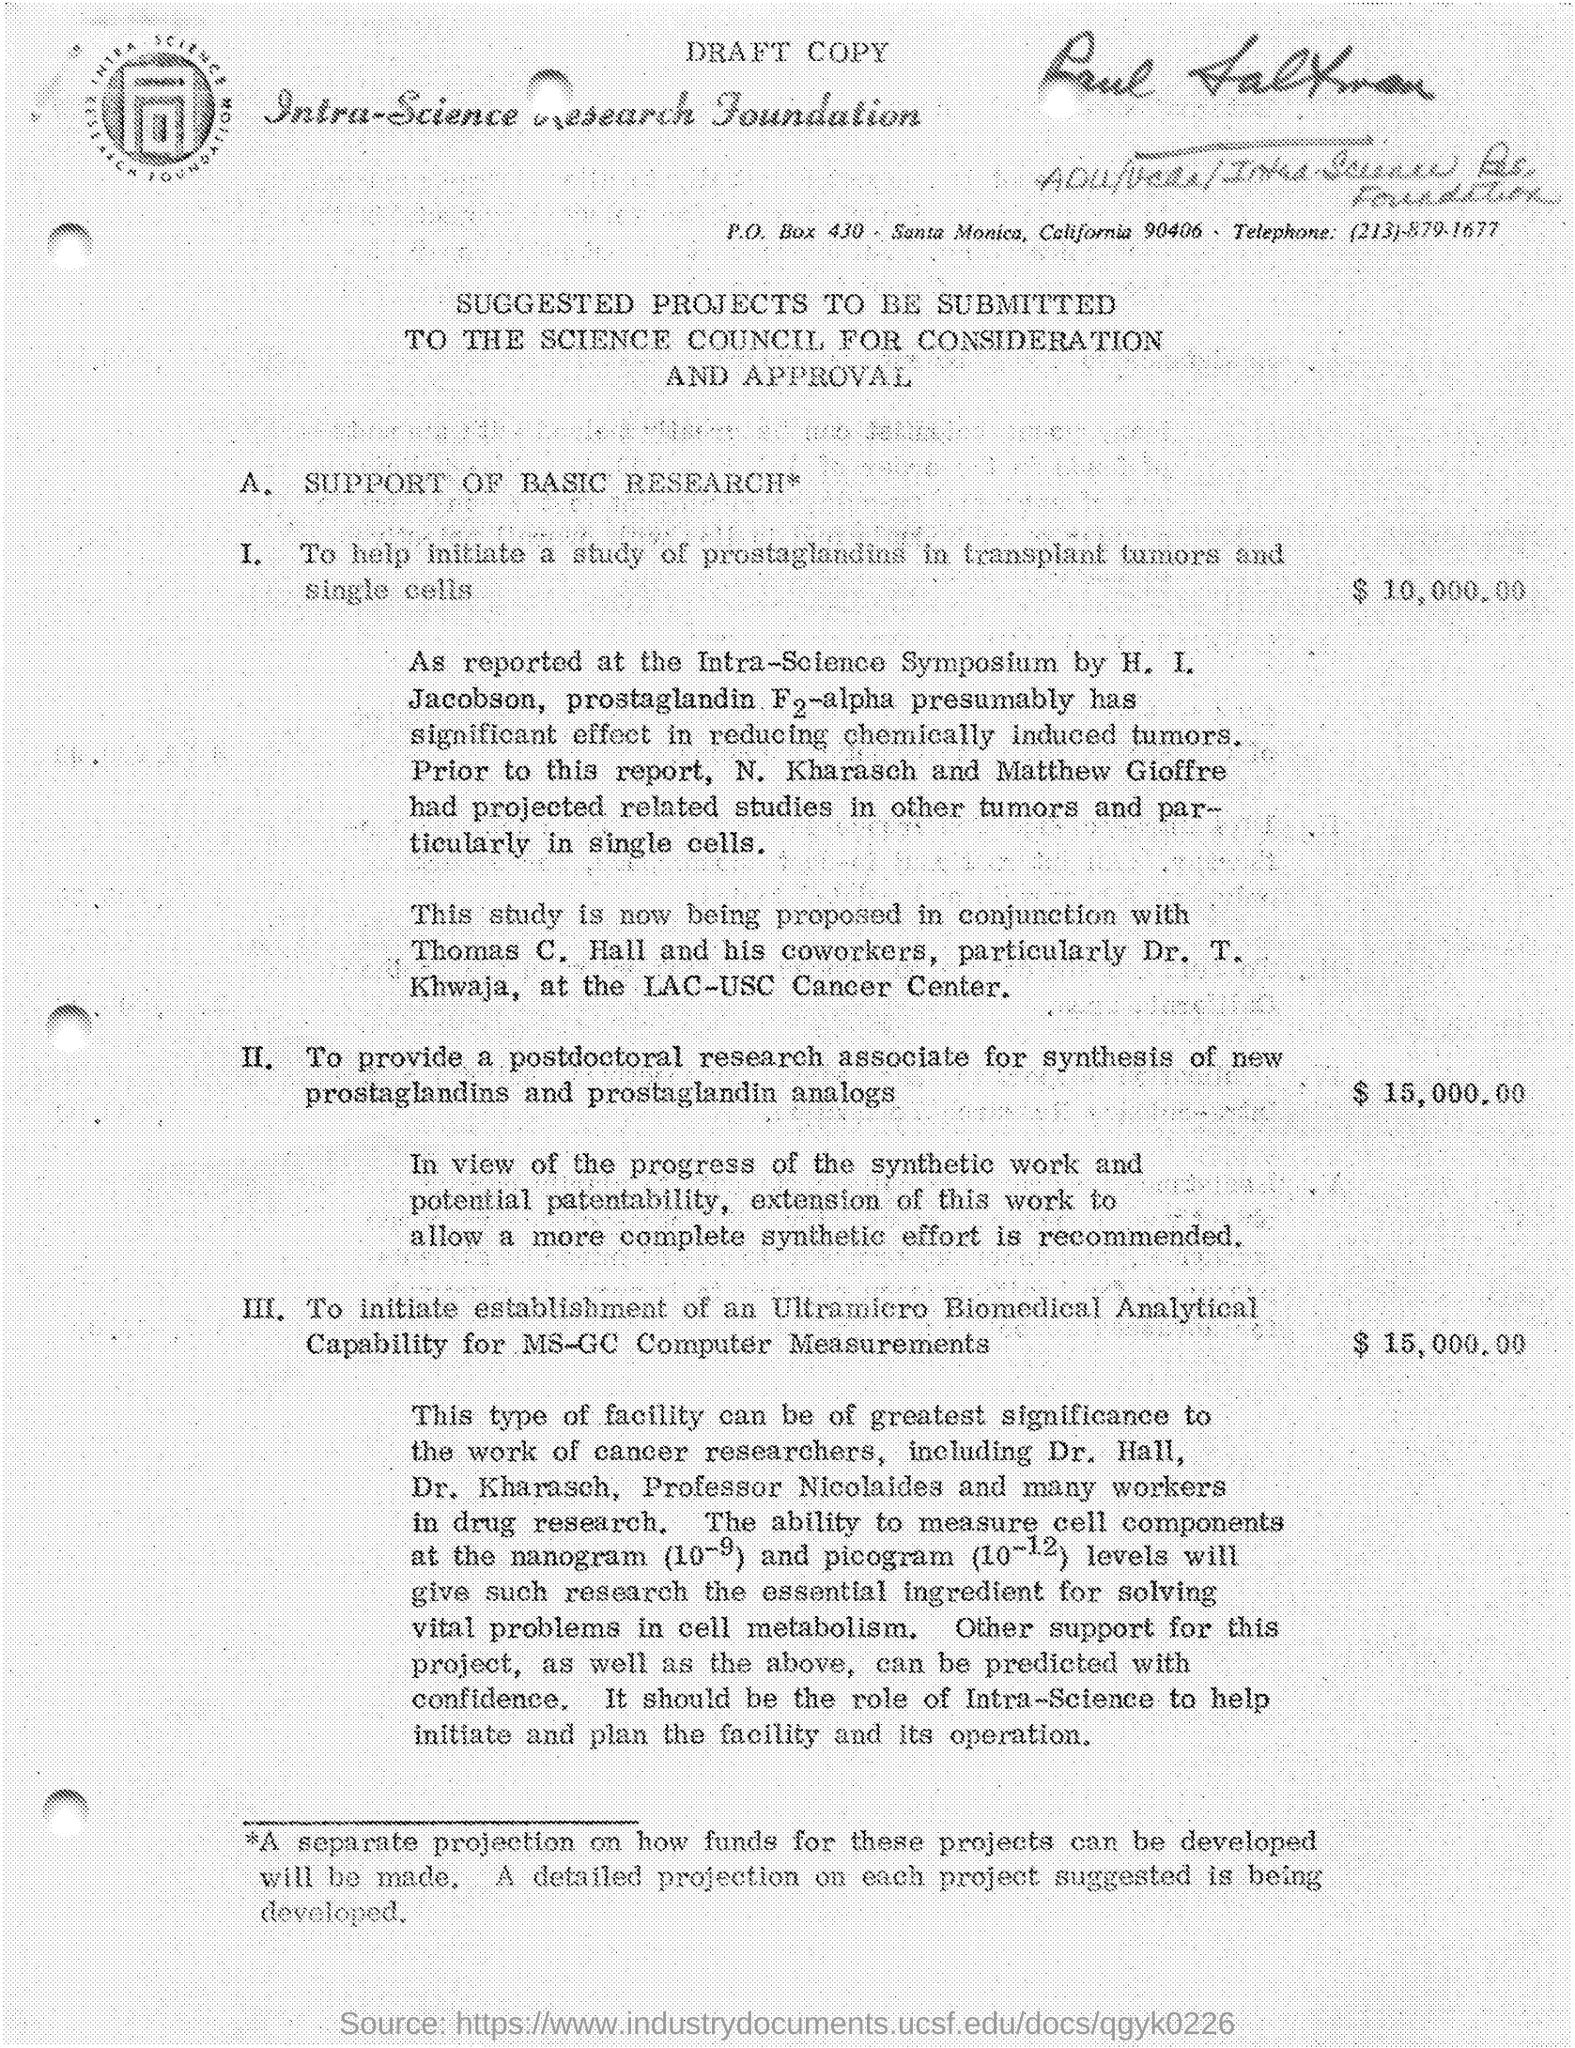Highlight a few significant elements in this photo. The PO Box number mentioned in the document is 430. The telephone number is (213)-879-1677. 